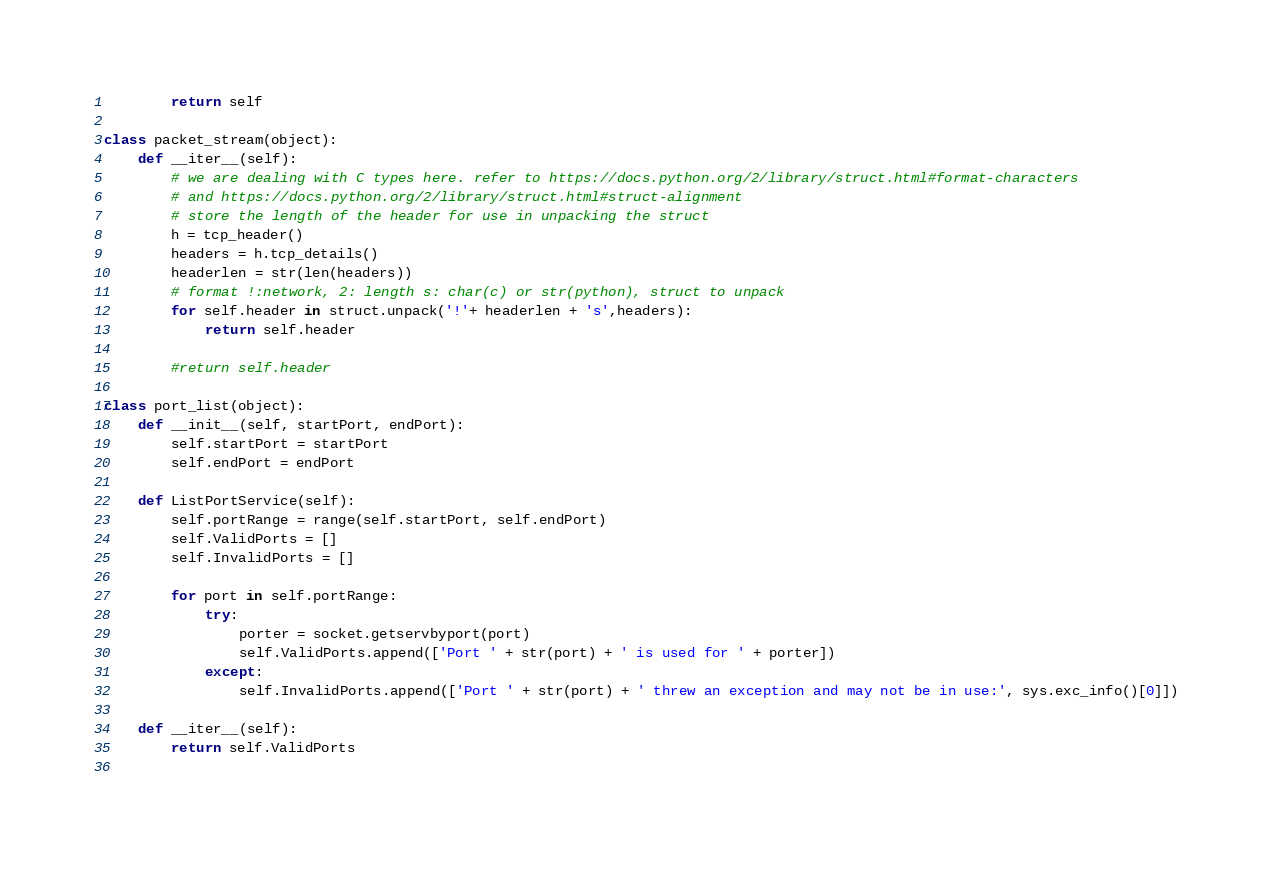Convert code to text. <code><loc_0><loc_0><loc_500><loc_500><_Python_>        return self

class packet_stream(object):
    def __iter__(self):
        # we are dealing with C types here. refer to https://docs.python.org/2/library/struct.html#format-characters
        # and https://docs.python.org/2/library/struct.html#struct-alignment
        # store the length of the header for use in unpacking the struct
        h = tcp_header()
        headers = h.tcp_details()
        headerlen = str(len(headers))
        # format !:network, 2: length s: char(c) or str(python), struct to unpack
        for self.header in struct.unpack('!'+ headerlen + 's',headers):
            return self.header

        #return self.header

class port_list(object):
    def __init__(self, startPort, endPort):
        self.startPort = startPort
        self.endPort = endPort

    def ListPortService(self):
        self.portRange = range(self.startPort, self.endPort)
        self.ValidPorts = []
        self.InvalidPorts = []

        for port in self.portRange:
            try:
                porter = socket.getservbyport(port)
                self.ValidPorts.append(['Port ' + str(port) + ' is used for ' + porter])
            except:
                self.InvalidPorts.append(['Port ' + str(port) + ' threw an exception and may not be in use:', sys.exc_info()[0]])

    def __iter__(self):
        return self.ValidPorts
        </code> 